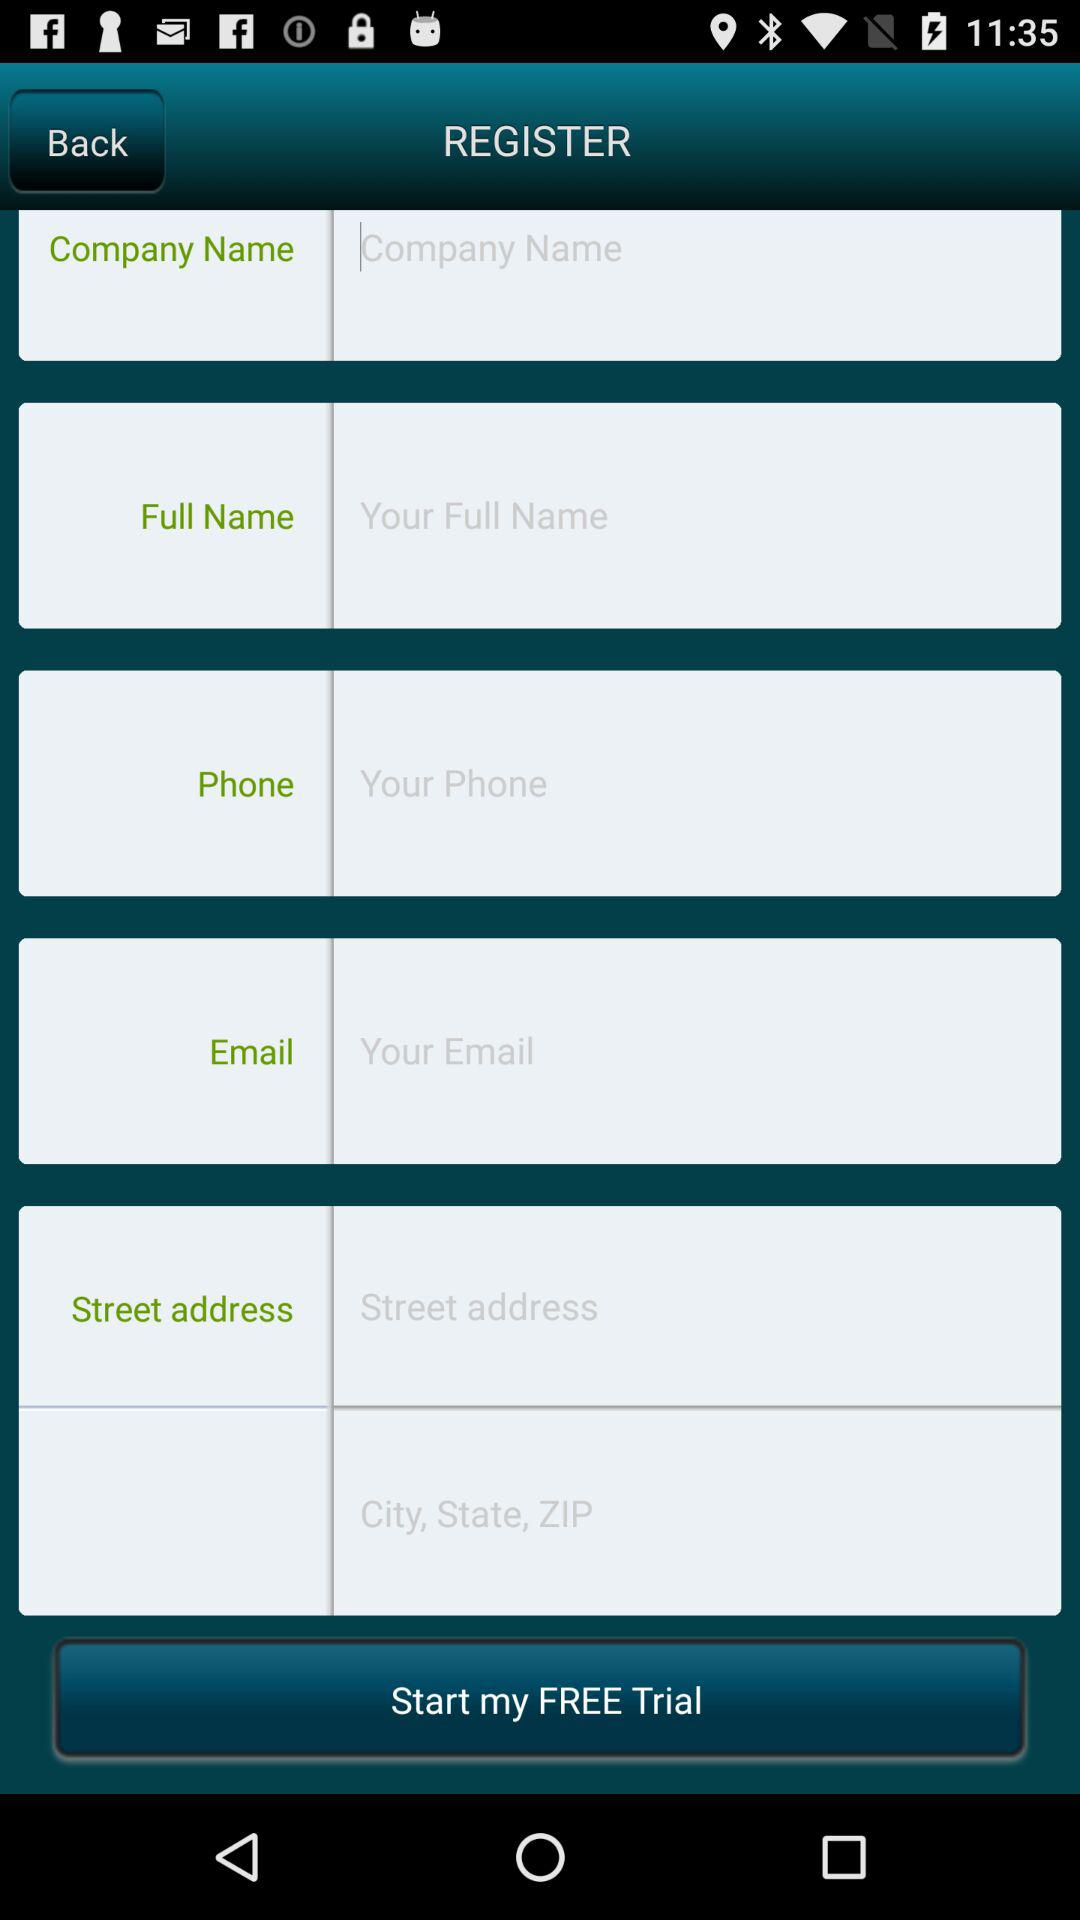How many text inputs are on the screen?
Answer the question using a single word or phrase. 6 